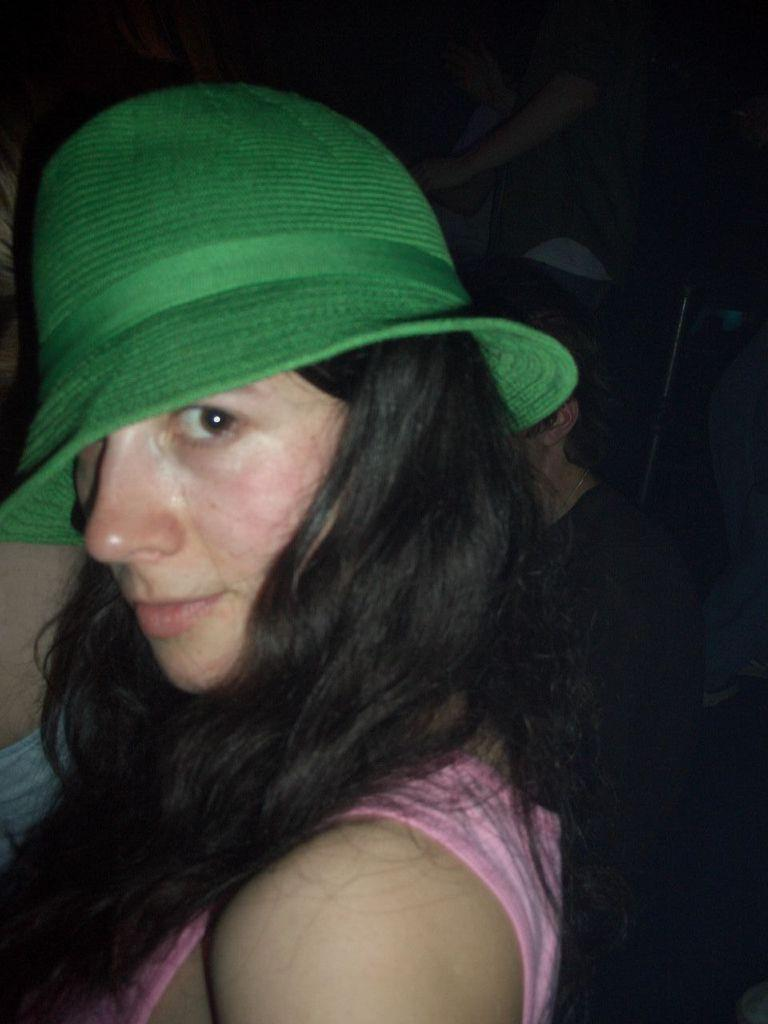What is the main subject of the image? There is a woman standing in the center of the image. What is the woman wearing on her head? The woman is wearing a green hat. Can you describe the presence of any other people in the image? Yes, there are two persons standing in the background of the image. How many stems can be seen growing from the woman's eyes in the image? There are no stems growing from the woman's eyes in the image; this is not a factual detail about the image. 